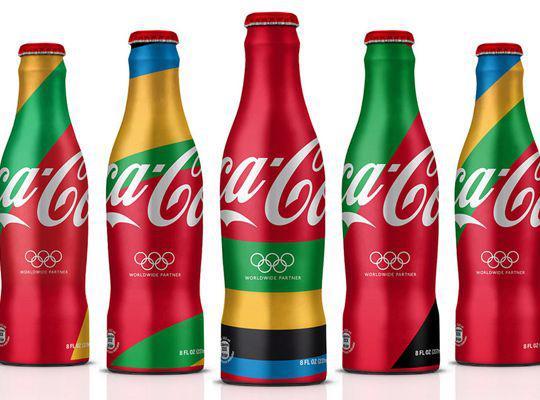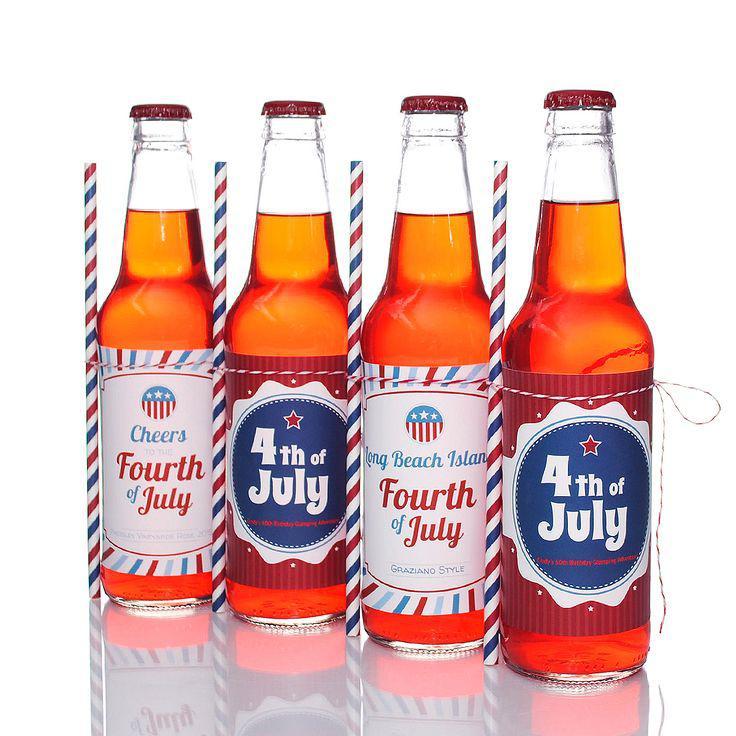The first image is the image on the left, the second image is the image on the right. Examine the images to the left and right. Is the description "In one of the images, all of the bottles are Coca-Cola bottles." accurate? Answer yes or no. Yes. The first image is the image on the left, the second image is the image on the right. Evaluate the accuracy of this statement regarding the images: "The left image includes at least three metallic-looking, multicolored bottles with red caps in a row, with the middle bottle slightly forward.". Is it true? Answer yes or no. Yes. 